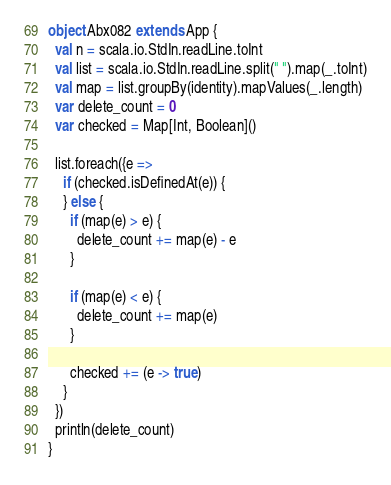Convert code to text. <code><loc_0><loc_0><loc_500><loc_500><_Scala_>object Abx082 extends App {
  val n = scala.io.StdIn.readLine.toInt
  val list = scala.io.StdIn.readLine.split(" ").map(_.toInt)
  val map = list.groupBy(identity).mapValues(_.length)
  var delete_count = 0
  var checked = Map[Int, Boolean]()

  list.foreach({e =>
    if (checked.isDefinedAt(e)) {
    } else {
      if (map(e) > e) {
        delete_count += map(e) - e
      }

      if (map(e) < e) {
        delete_count += map(e)
      }

      checked += (e -> true)
    }
  })
  println(delete_count)
}
</code> 